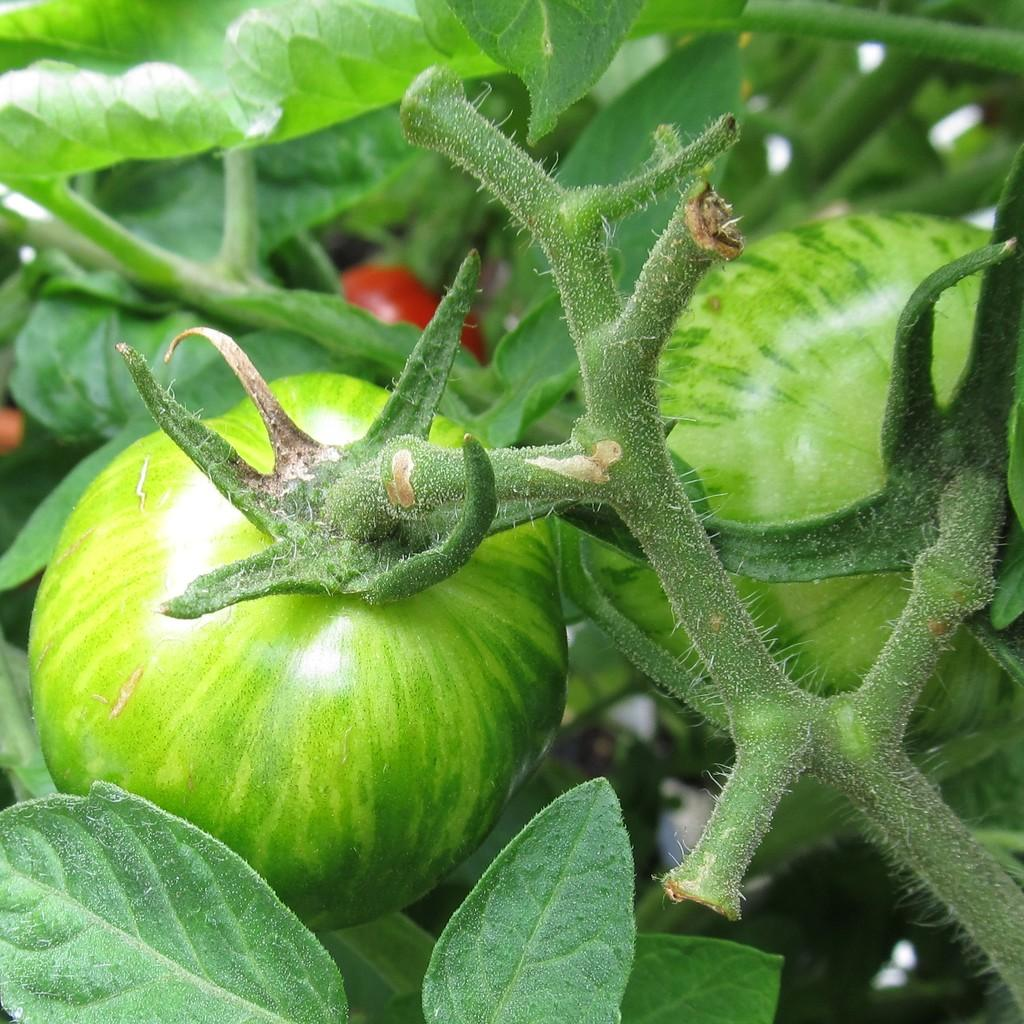What type of food can be seen in the image? There are fruits in the image. What parts of the plants are visible in the image? There are plant stems and leaves in the image. What is the income of the fruit expert in the image? There is no fruit expert or income mentioned in the image; it only shows fruits, plant stems, and leaves. 